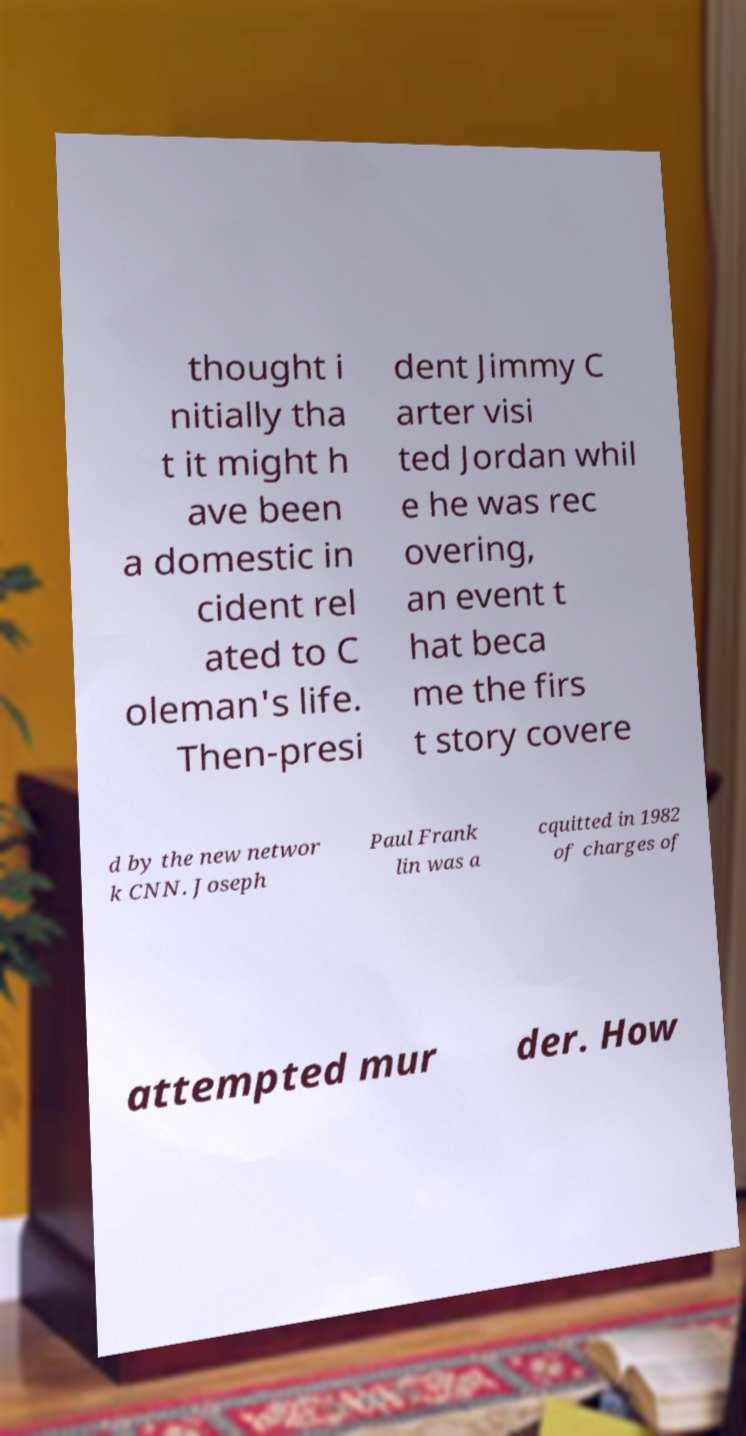For documentation purposes, I need the text within this image transcribed. Could you provide that? thought i nitially tha t it might h ave been a domestic in cident rel ated to C oleman's life. Then-presi dent Jimmy C arter visi ted Jordan whil e he was rec overing, an event t hat beca me the firs t story covere d by the new networ k CNN. Joseph Paul Frank lin was a cquitted in 1982 of charges of attempted mur der. How 